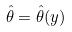Convert formula to latex. <formula><loc_0><loc_0><loc_500><loc_500>\hat { \theta } = \hat { \theta } ( y )</formula> 